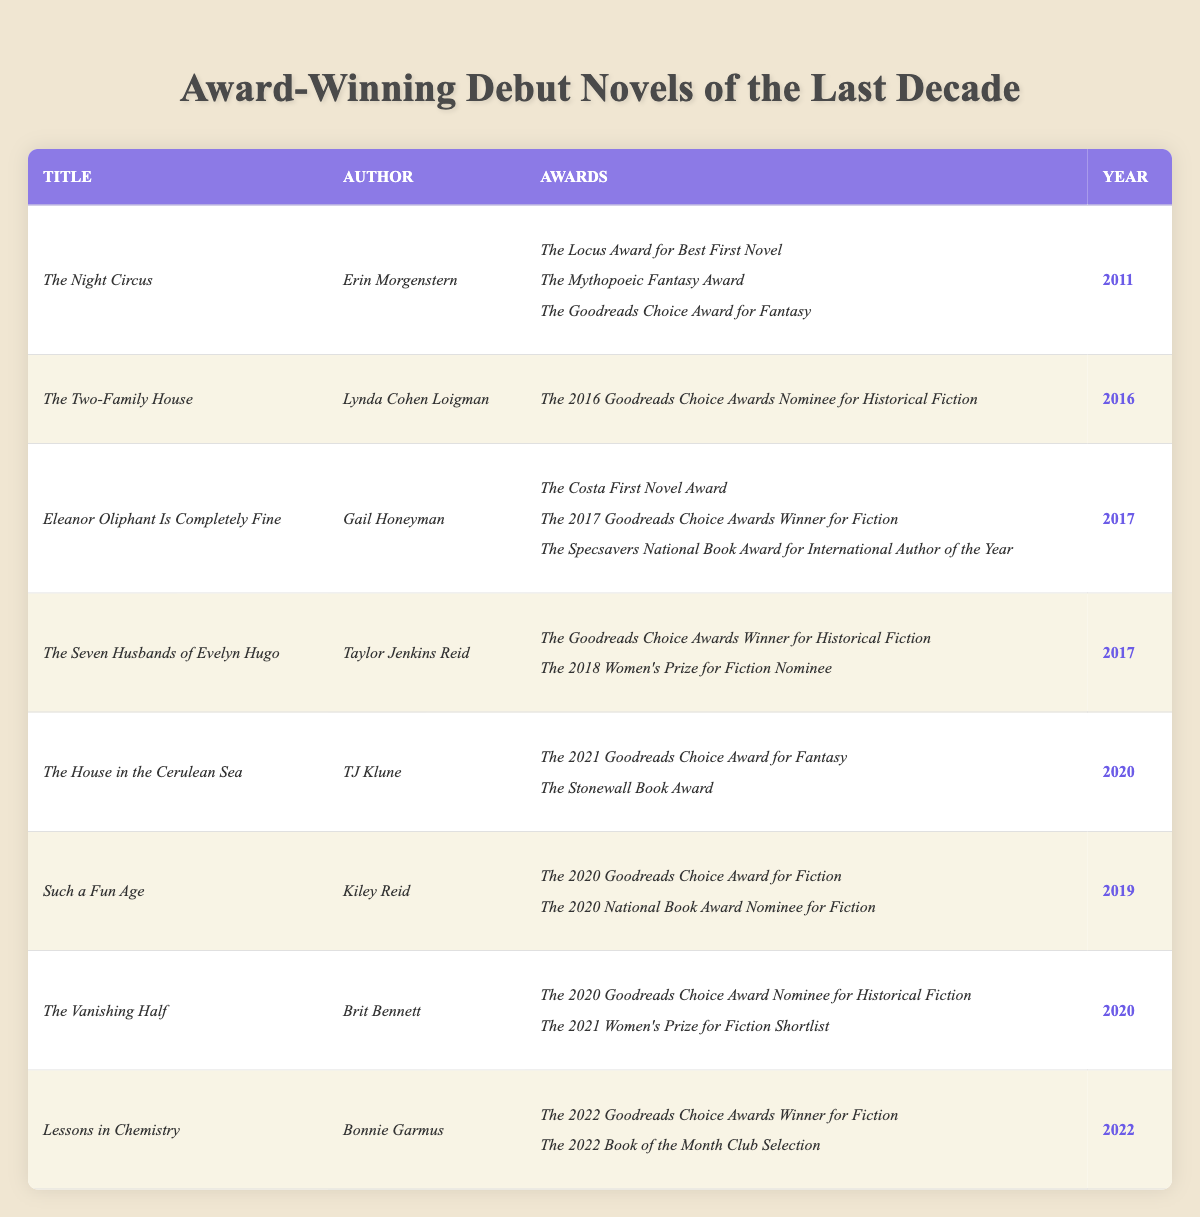What is the title of the debut novel that won the 2022 Goodreads Choice Award for Fiction? The table lists the awards won by various debut novels. Looking at the "Awards" column, I find that *Lessons in Chemistry* is the only novel that won the 2022 Goodreads Choice Award for Fiction.
Answer: *Lessons in Chemistry* Which author received the Costa First Novel Award for their debut? Referring to the table, *Eleanor Oliphant Is Completely Fine* by *Gail Honeyman* is noted as the winner of the Costa First Novel Award.
Answer: *Gail Honeyman* How many awards did *The Night Circus* win? Checking the awards listed for *The Night Circus*, I see there are three awards specified: The Locus Award for Best First Novel, The Mythopoeic Fantasy Award, and The Goodreads Choice Award for Fantasy. Therefore, it won a total of three awards.
Answer: 3 What is the most recent year listed in the table? The last entry in the table is for the year 2022 for *Lessons in Chemistry*, making it the most recent year in the data provided.
Answer: 2022 Did *Such a Fun Age* win any awards? In the "Awards" section for *Such a Fun Age*, it is shown to be a winner of the 2020 Goodreads Choice Award for Fiction. Thus, it won at least one award.
Answer: Yes Which debut novel was nominated for the 2018 Women’s Prize for Fiction? The table indicates that *The Seven Husbands of Evelyn Hugo* is the only debut novel nominated for the 2018 Women’s Prize for Fiction.
Answer: *The Seven Husbands of Evelyn Hugo* How many different awards did *Eleanor Oliphant Is Completely Fine* receive compared to *The House in the Cerulean Sea*? Looking at *Eleanor Oliphant Is Completely Fine*, it received three awards. *The House in the Cerulean Sea* won two awards. The difference in the number of awards is 3 - 2 = 1.
Answer: 1 Are there any debut novels that were nominated for multiple awards? Referring to the table, I note that *Eleanor Oliphant Is Completely Fine* has three nominations, while *The Vanishing Half* and *Such a Fun Age* have two nominations each. Since there are novels with multiple nominations, the answer is yes.
Answer: Yes Which author has the most awards for their debut novel? By analyzing the table, *Eleanor Oliphant Is Completely Fine* has three awards, the highest count among the entries. Although *The Night Circus* also has three, *Gail Honeyman* is the first to have three awards listed in the table.
Answer: *Gail Honeyman* What is the difference in years between the debut novels of *Kiley Reid* and *Bonnie Garmus*? *Such a Fun Age*, authored by *Kiley Reid*, was published in 2019, while *Lessons in Chemistry*, authored by *Bonnie Garmus*, came out in 2022. The difference in years is 2022 - 2019 = 3.
Answer: 3 